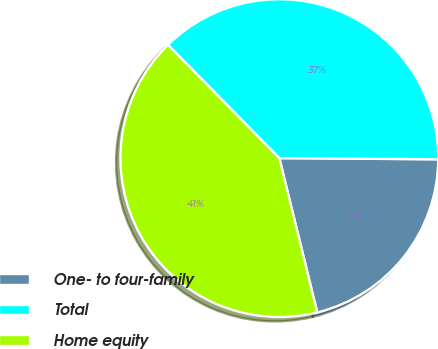Convert chart. <chart><loc_0><loc_0><loc_500><loc_500><pie_chart><fcel>One- to four-family<fcel>Total<fcel>Home equity<nl><fcel>21.05%<fcel>37.49%<fcel>41.46%<nl></chart> 